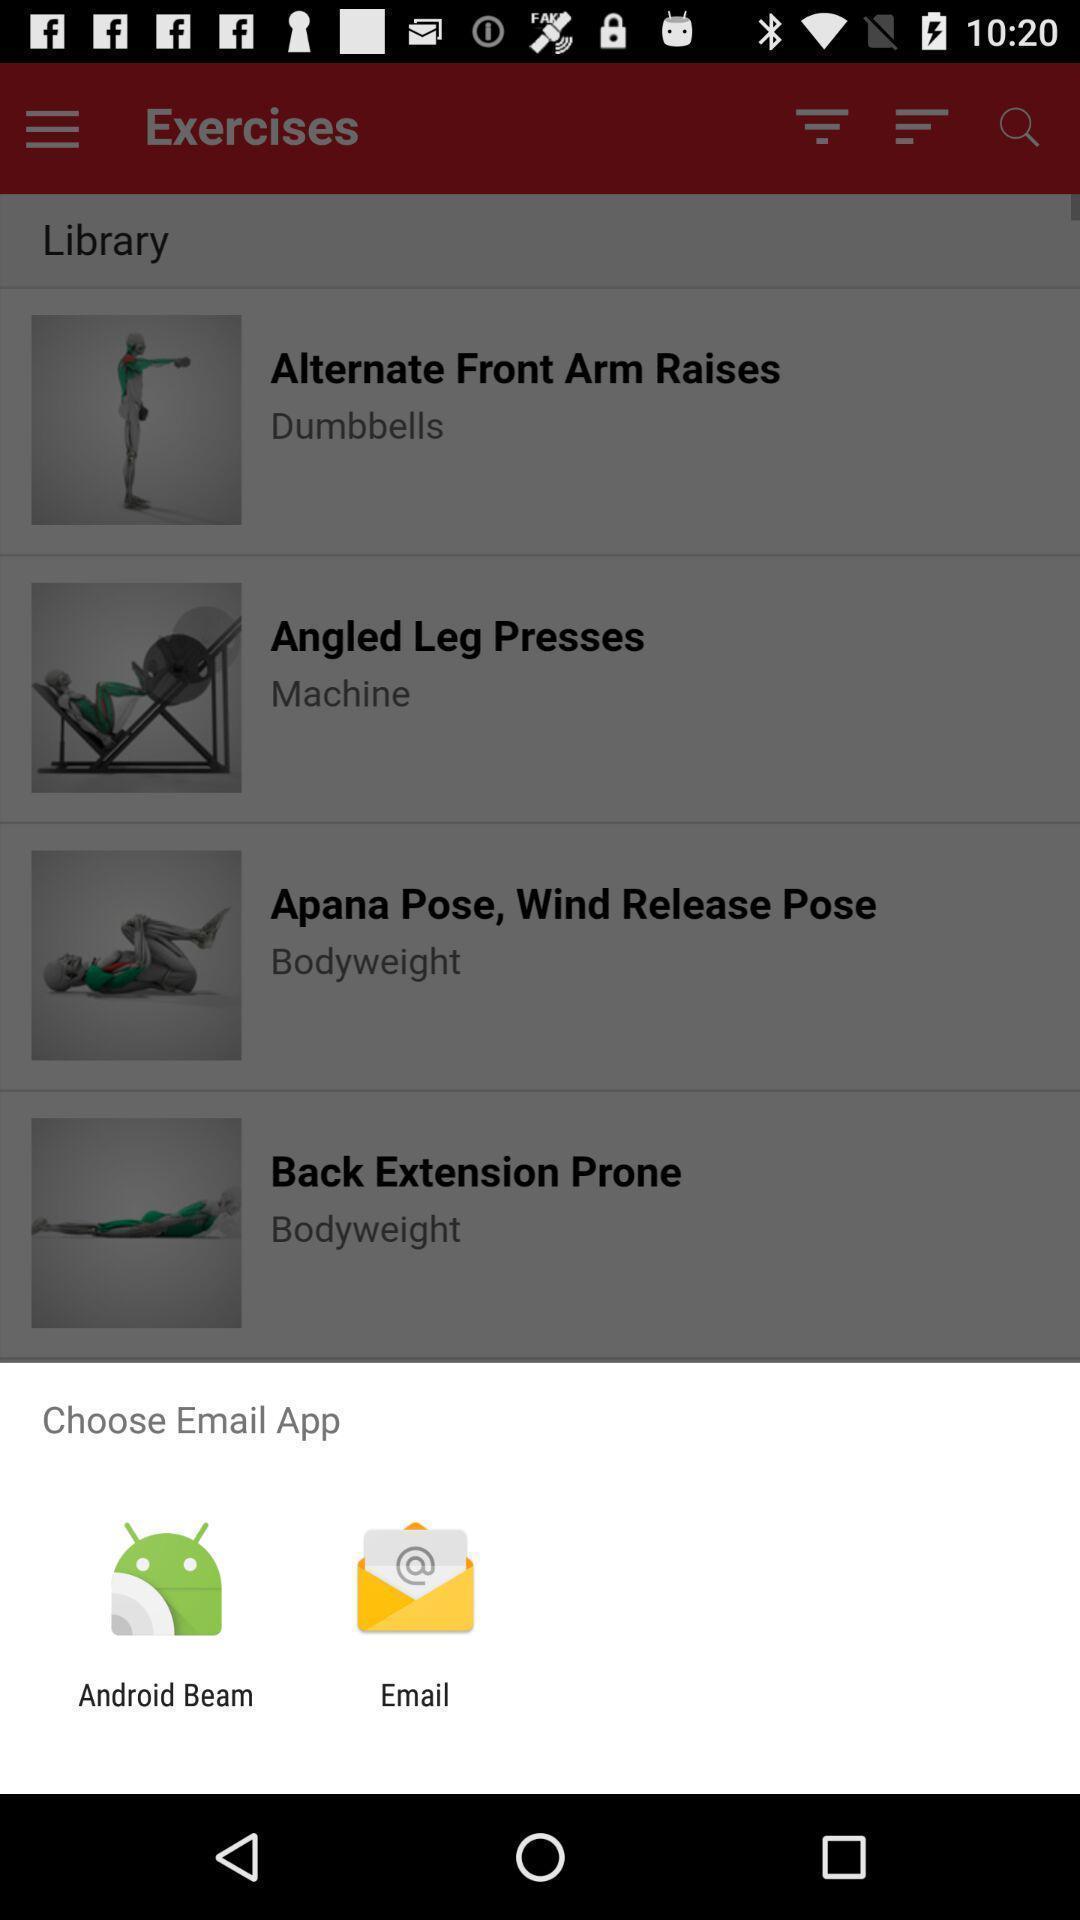Describe the visual elements of this screenshot. Popup of applications to share the mail in mobile. 